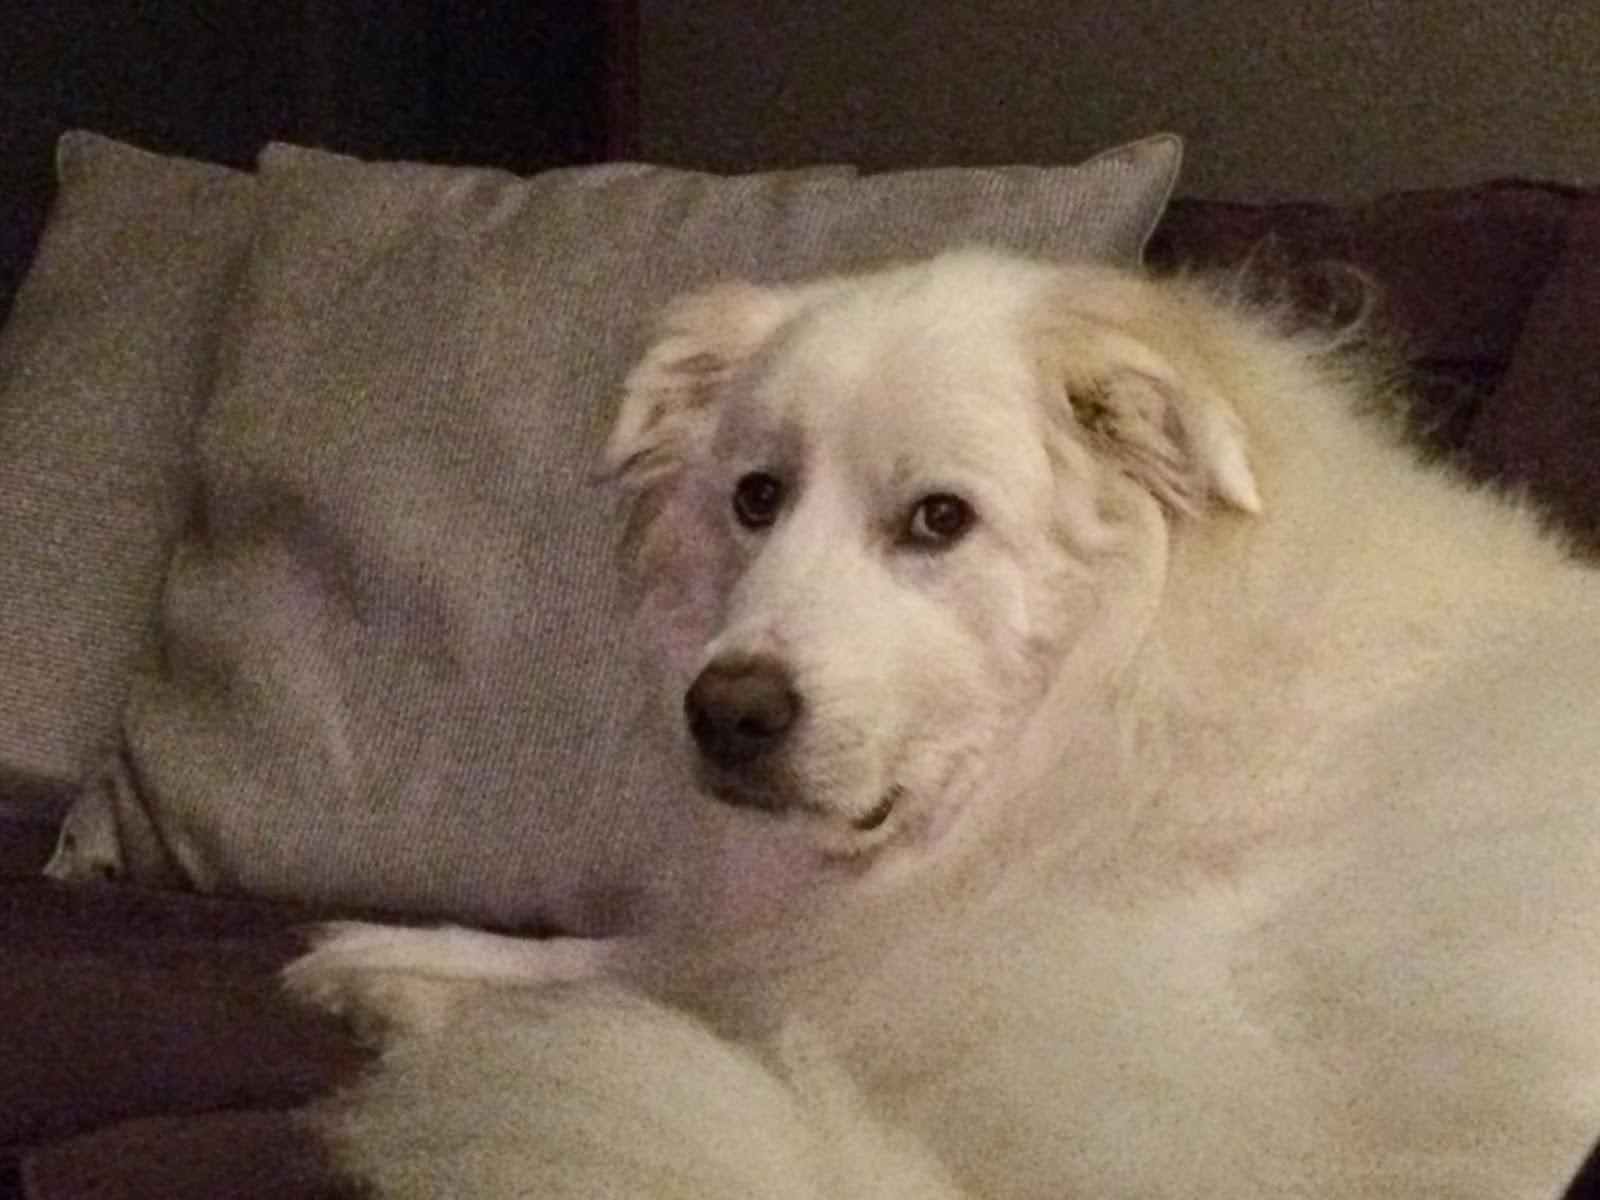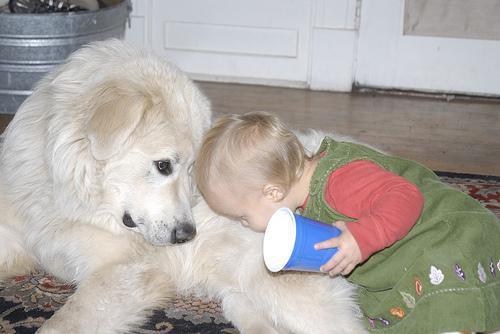The first image is the image on the left, the second image is the image on the right. Evaluate the accuracy of this statement regarding the images: "One of the pictures shows a puppy sleeping alone.". Is it true? Answer yes or no. No. The first image is the image on the left, the second image is the image on the right. Analyze the images presented: Is the assertion "One image shows a single reclining white puppy with at least one front paw forward, and the other image shows a white dog reclining with a 'real' sleeping hooved animal." valid? Answer yes or no. No. 